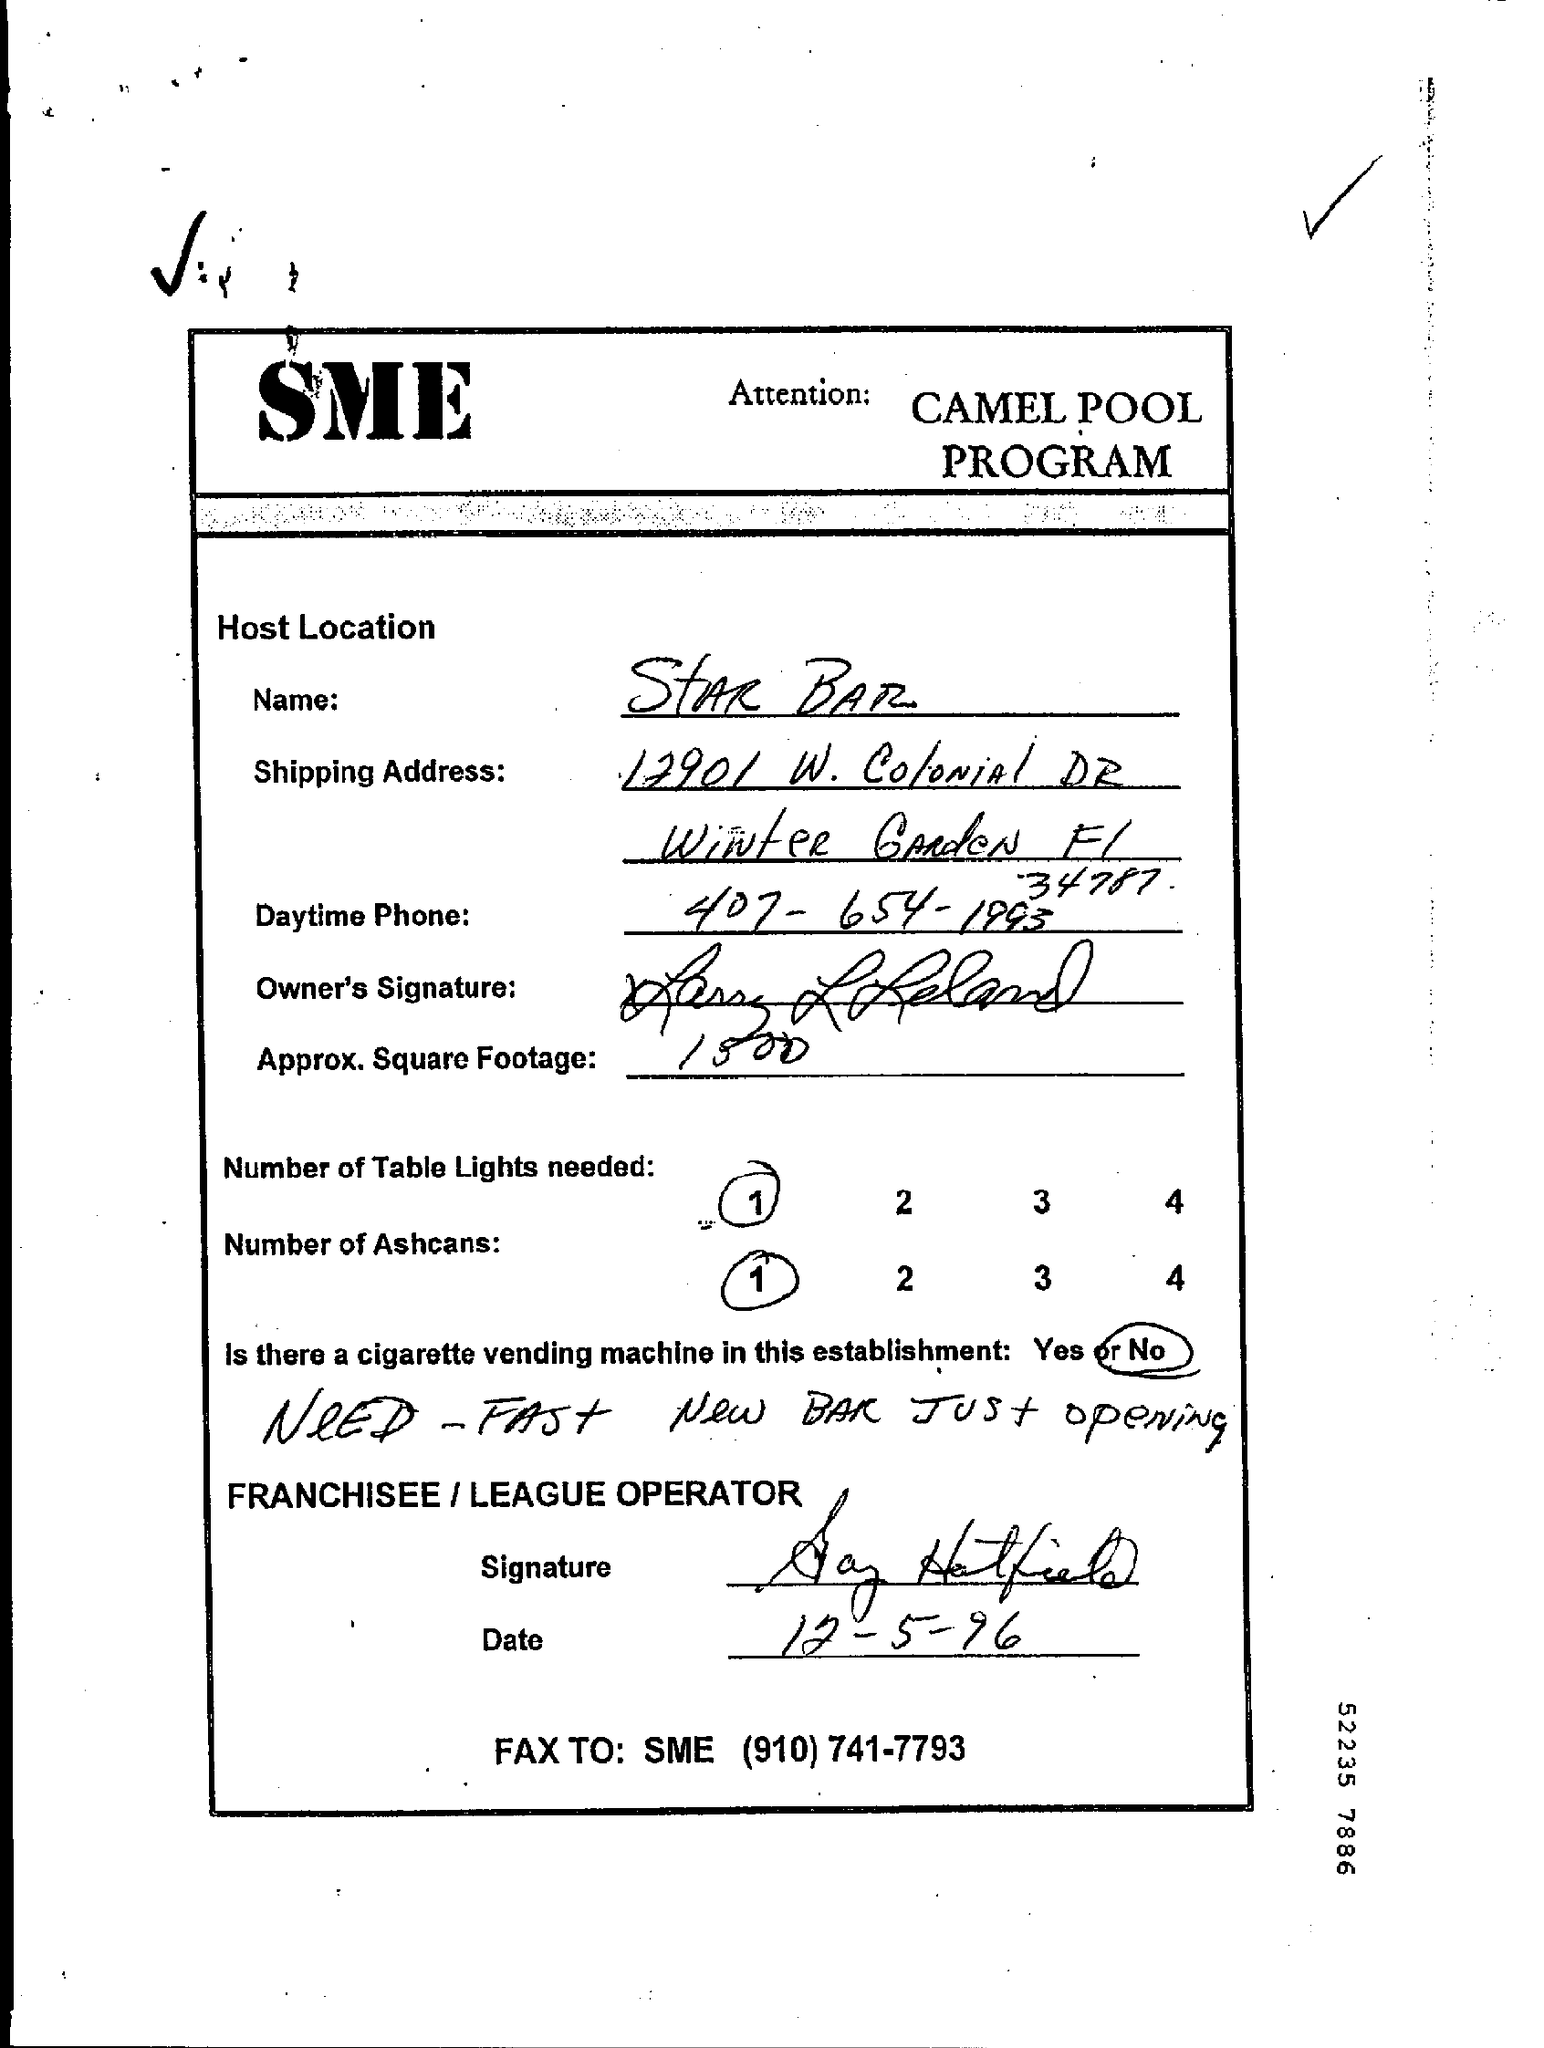Give some essential details in this illustration. There is no cigarette vending machine located within this establishment. The number of ashcans required, as specified in the provided page, is 1... The day time phone number provided on the page is 407-654-1993. The name of the host location is Star Bar. The name of the program is the Camel Pool program. 